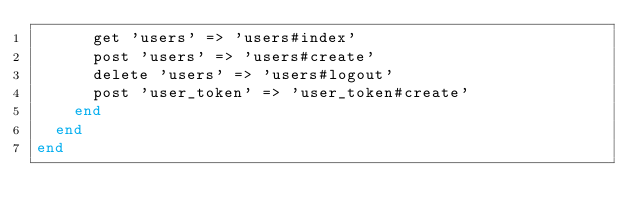Convert code to text. <code><loc_0><loc_0><loc_500><loc_500><_Ruby_>      get 'users' => 'users#index'
      post 'users' => 'users#create'
      delete 'users' => 'users#logout'
      post 'user_token' => 'user_token#create'
    end
  end
end
</code> 